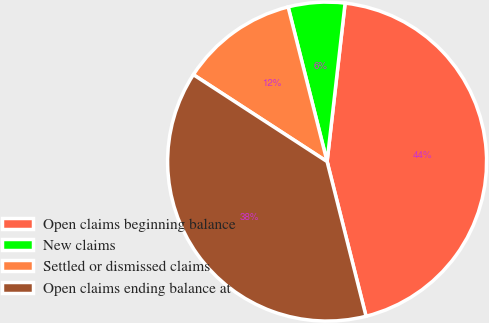Convert chart to OTSL. <chart><loc_0><loc_0><loc_500><loc_500><pie_chart><fcel>Open claims beginning balance<fcel>New claims<fcel>Settled or dismissed claims<fcel>Open claims ending balance at<nl><fcel>44.27%<fcel>5.73%<fcel>11.9%<fcel>38.1%<nl></chart> 